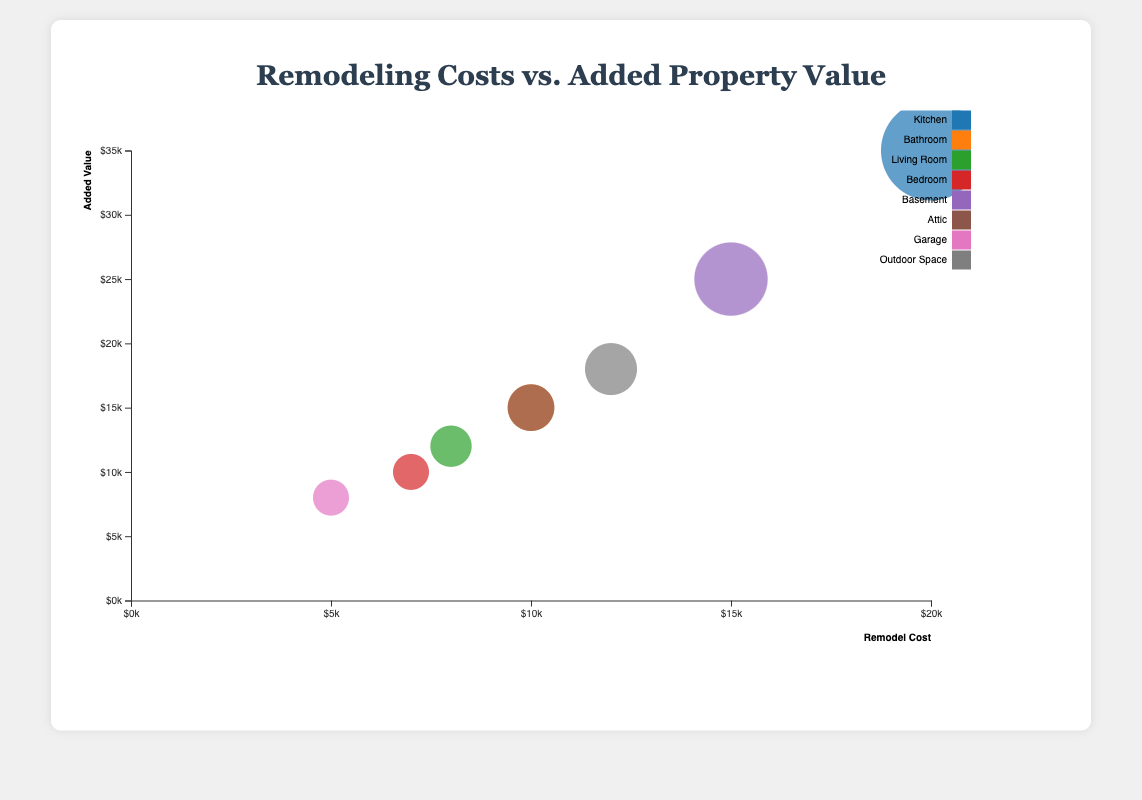What is the title of the chart? The title is usually located at the top of the chart, and in this case, we can see it reads "Remodeling Costs vs. Added Property Value".
Answer: Remodeling Costs vs. Added Property Value How many different room types are represented in the data? We can identify each room type by looking at the number of different colors in the legend on the right of the chart. Each different color represents a distinct room type. The room types shown are Kitchen, Bathroom, Living Room, Bedroom, Basement, Attic, Garage, and Outdoor Space.
Answer: 8 Which project gives the highest added value? To find the highest added value, we should look for the bubble that is positioned highest on the vertical axis (Added Value). In this case, the "Modern Family Kitchen" with an added value of $35,000 is the highest.
Answer: Modern Family Kitchen What is the total remodel cost for the projects that have added value over $20,000? The bubbles corresponding to added values over $20,000 are "Modern Family Kitchen" ($20,000) and "Finished Basement" ($15,000). Summing their remodel costs gives 20,000 + 15,000.
Answer: $35,000 Which room type has the bubble with the largest radius? The size of the bubble correlates with the difference between added value and remodel cost. The biggest bubble appears to be for the project "Modern Family Kitchen".
Answer: Kitchen What is the ratio of added value to remodel cost for the "Luxury Bath" project? To find the ratio, divide the added value by the remodel cost for the "Luxury Bath" project: $15,000 / $10,000 = 1.5.
Answer: 1.5 Which project has the smallest added value increase compared to its remodel cost? To identify the smallest increase, look for the smallest bubble. The "Garage Expansion" project has the smallest increase, with added value of $8,000 and remodel cost of $5,000, making the difference $3,000.
Answer: Garage Expansion Which project shows the highest return on investment (ROI) and what is its ROI percentage? ROI can be calculated by (AddedValue - RemodelCost) / RemodelCost * 100%. For "Modern Family Kitchen", the calculation is (35000 - 20000) / 20000 * 100% = 75%.
Answer: Modern Family Kitchen, 75% If you had $15,000 to spend on remodeling, which project adds the most value within your budget? Considering the projects with a remodel cost of $15,000 or less, the "Finished Basement" project stands out as it adds $25,000 in value.
Answer: Finished Basement 